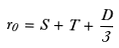Convert formula to latex. <formula><loc_0><loc_0><loc_500><loc_500>r _ { 0 } = S + T + \frac { D } { 3 }</formula> 